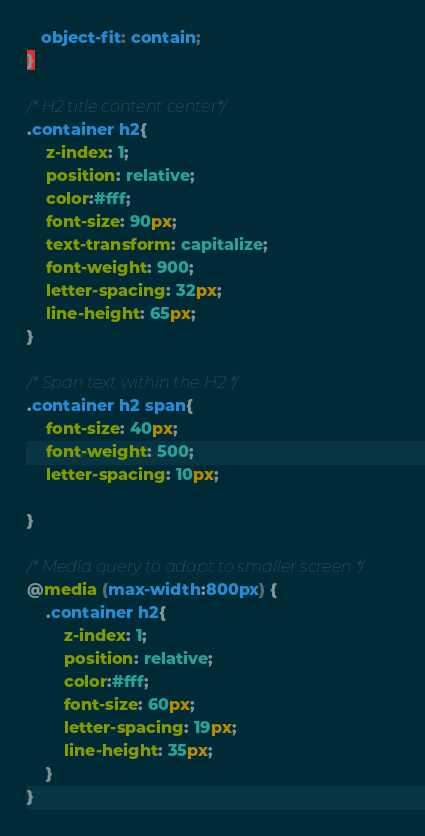<code> <loc_0><loc_0><loc_500><loc_500><_CSS_>   object-fit: contain;
}

/* H2 title content center*/
.container h2{
    z-index: 1;
    position: relative;
    color:#fff;
    font-size: 90px;
    text-transform: capitalize;
    font-weight: 900;
    letter-spacing: 32px;
    line-height: 65px;
}

/* Span text within the H2 */
.container h2 span{
    font-size: 40px;
    font-weight: 500;
    letter-spacing: 10px;

}

/* Media query to adapt to smaller screen */
@media (max-width:800px) {
    .container h2{
        z-index: 1;
        position: relative;
        color:#fff;
        font-size: 60px;
        letter-spacing: 19px;
        line-height: 35px;
    }  
}
</code> 